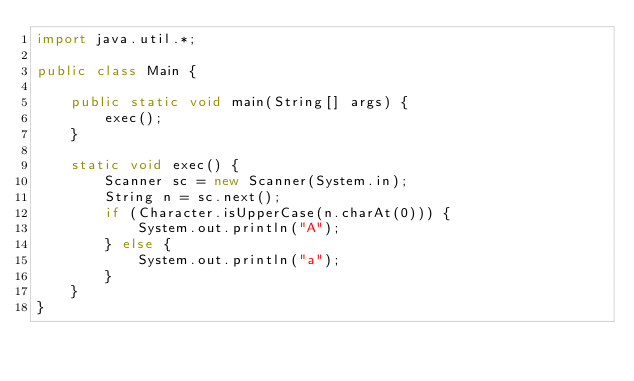Convert code to text. <code><loc_0><loc_0><loc_500><loc_500><_Java_>import java.util.*;

public class Main {

    public static void main(String[] args) {
        exec();
    }

    static void exec() {
        Scanner sc = new Scanner(System.in);
        String n = sc.next();
        if (Character.isUpperCase(n.charAt(0))) {
            System.out.println("A");
        } else {
            System.out.println("a");
        }
    }
}</code> 